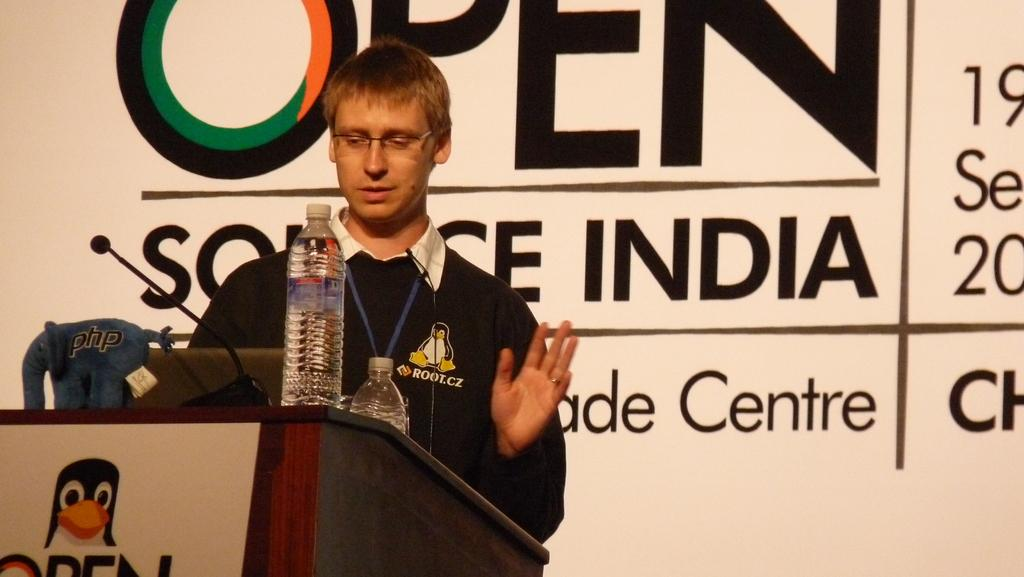<image>
Create a compact narrative representing the image presented. A man stands at a podium wearing a black top with root.cz on it in front of a large sign saying Open Source India. 